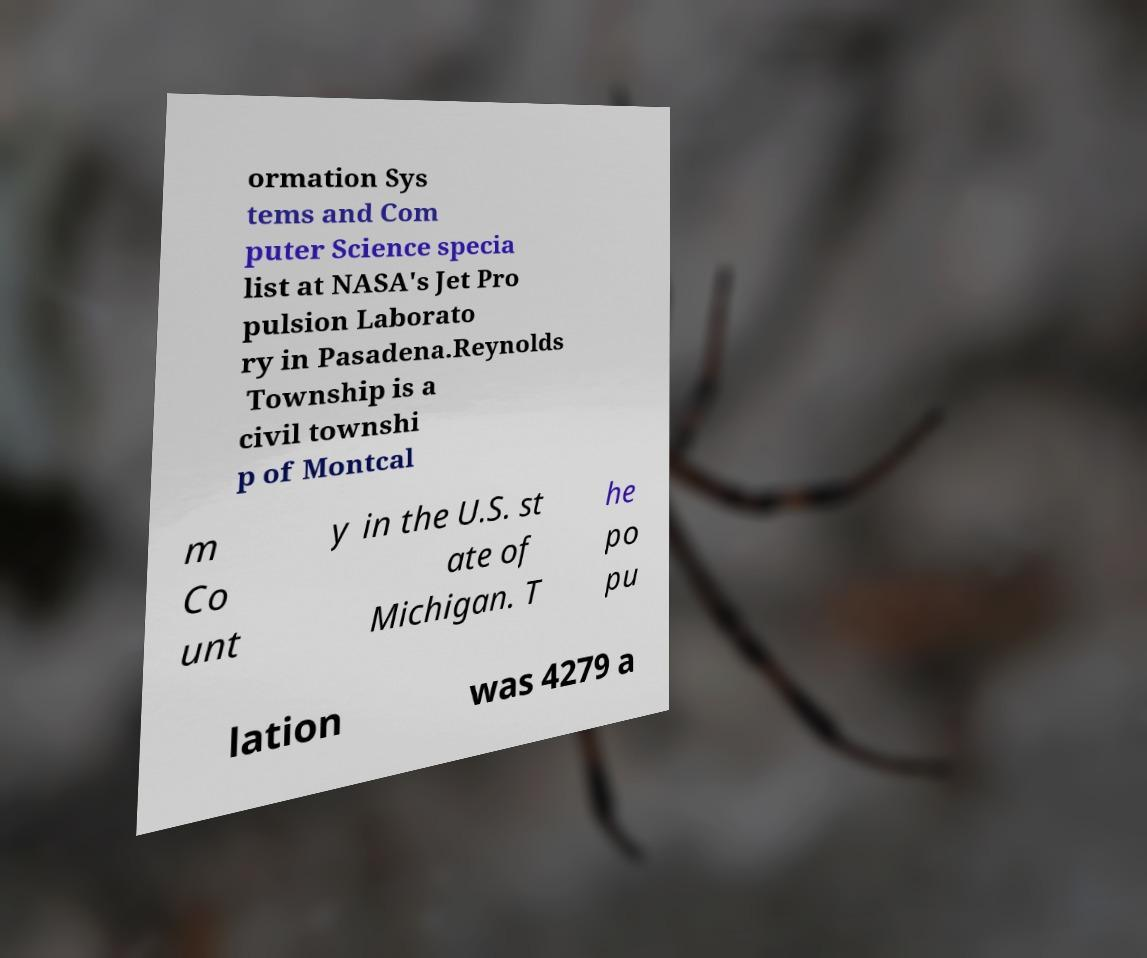Please identify and transcribe the text found in this image. ormation Sys tems and Com puter Science specia list at NASA's Jet Pro pulsion Laborato ry in Pasadena.Reynolds Township is a civil townshi p of Montcal m Co unt y in the U.S. st ate of Michigan. T he po pu lation was 4279 a 